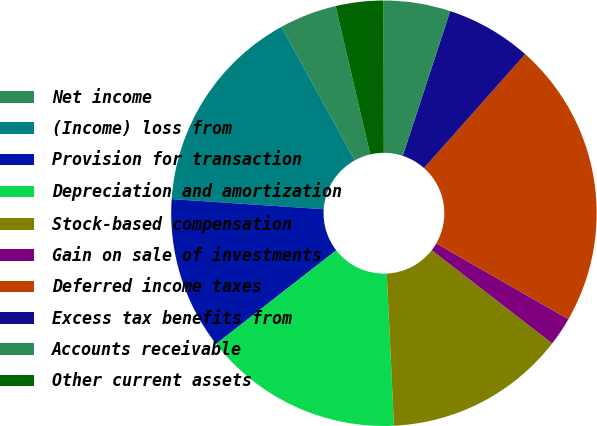Convert chart. <chart><loc_0><loc_0><loc_500><loc_500><pie_chart><fcel>Net income<fcel>(Income) loss from<fcel>Provision for transaction<fcel>Depreciation and amortization<fcel>Stock-based compensation<fcel>Gain on sale of investments<fcel>Deferred income taxes<fcel>Excess tax benefits from<fcel>Accounts receivable<fcel>Other current assets<nl><fcel>4.35%<fcel>15.94%<fcel>11.59%<fcel>15.22%<fcel>13.77%<fcel>2.18%<fcel>21.74%<fcel>6.52%<fcel>5.07%<fcel>3.62%<nl></chart> 